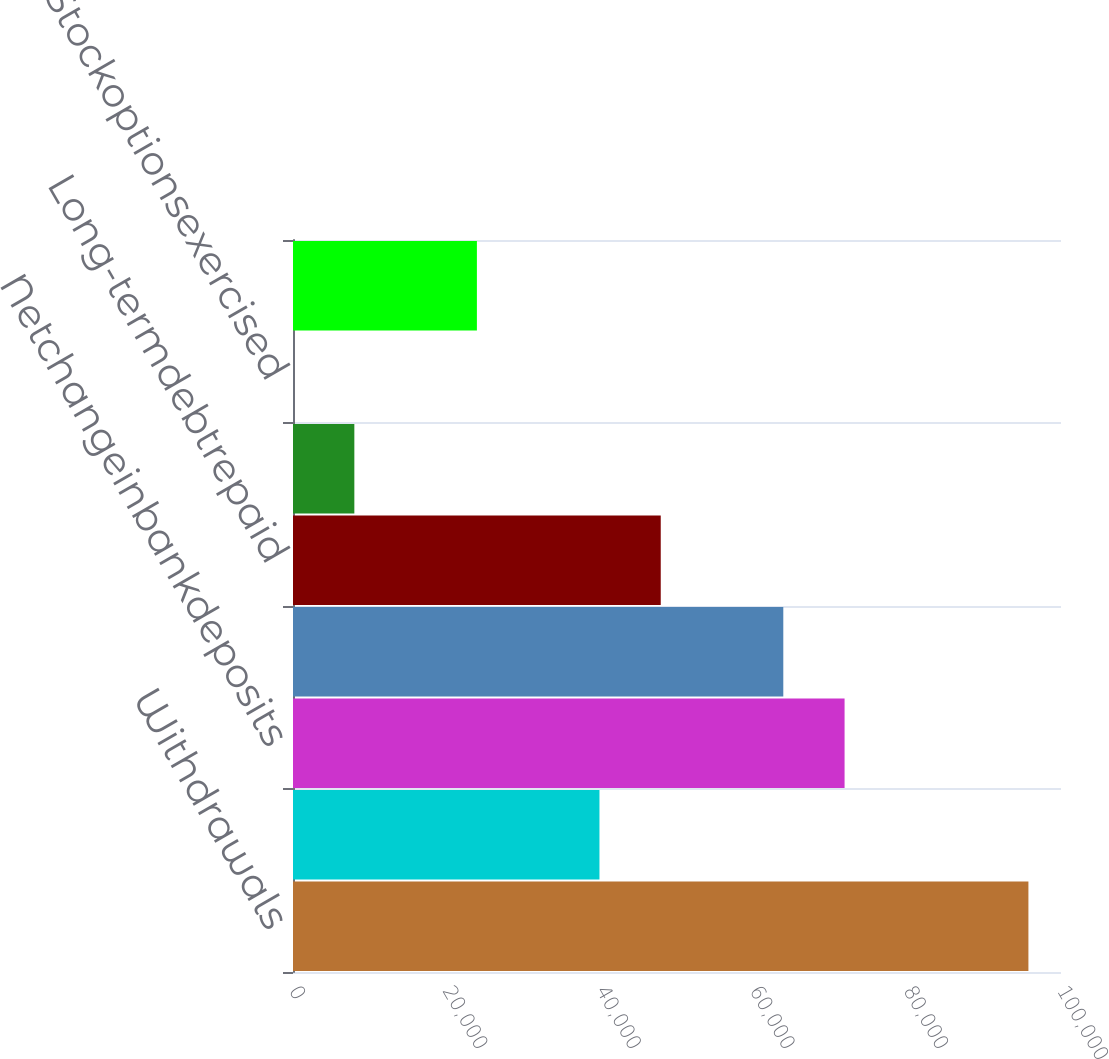Convert chart. <chart><loc_0><loc_0><loc_500><loc_500><bar_chart><fcel>Withdrawals<fcel>Unnamed: 1<fcel>Netchangeinbankdeposits<fcel>Netchangeinshort-termdebt<fcel>Long-termdebtrepaid<fcel>Debtissuancecosts<fcel>Stockoptionsexercised<fcel>Dividendsonpreferredstock<nl><fcel>95757.2<fcel>39903.5<fcel>71819.9<fcel>63840.8<fcel>47882.6<fcel>7987.1<fcel>8<fcel>23945.3<nl></chart> 